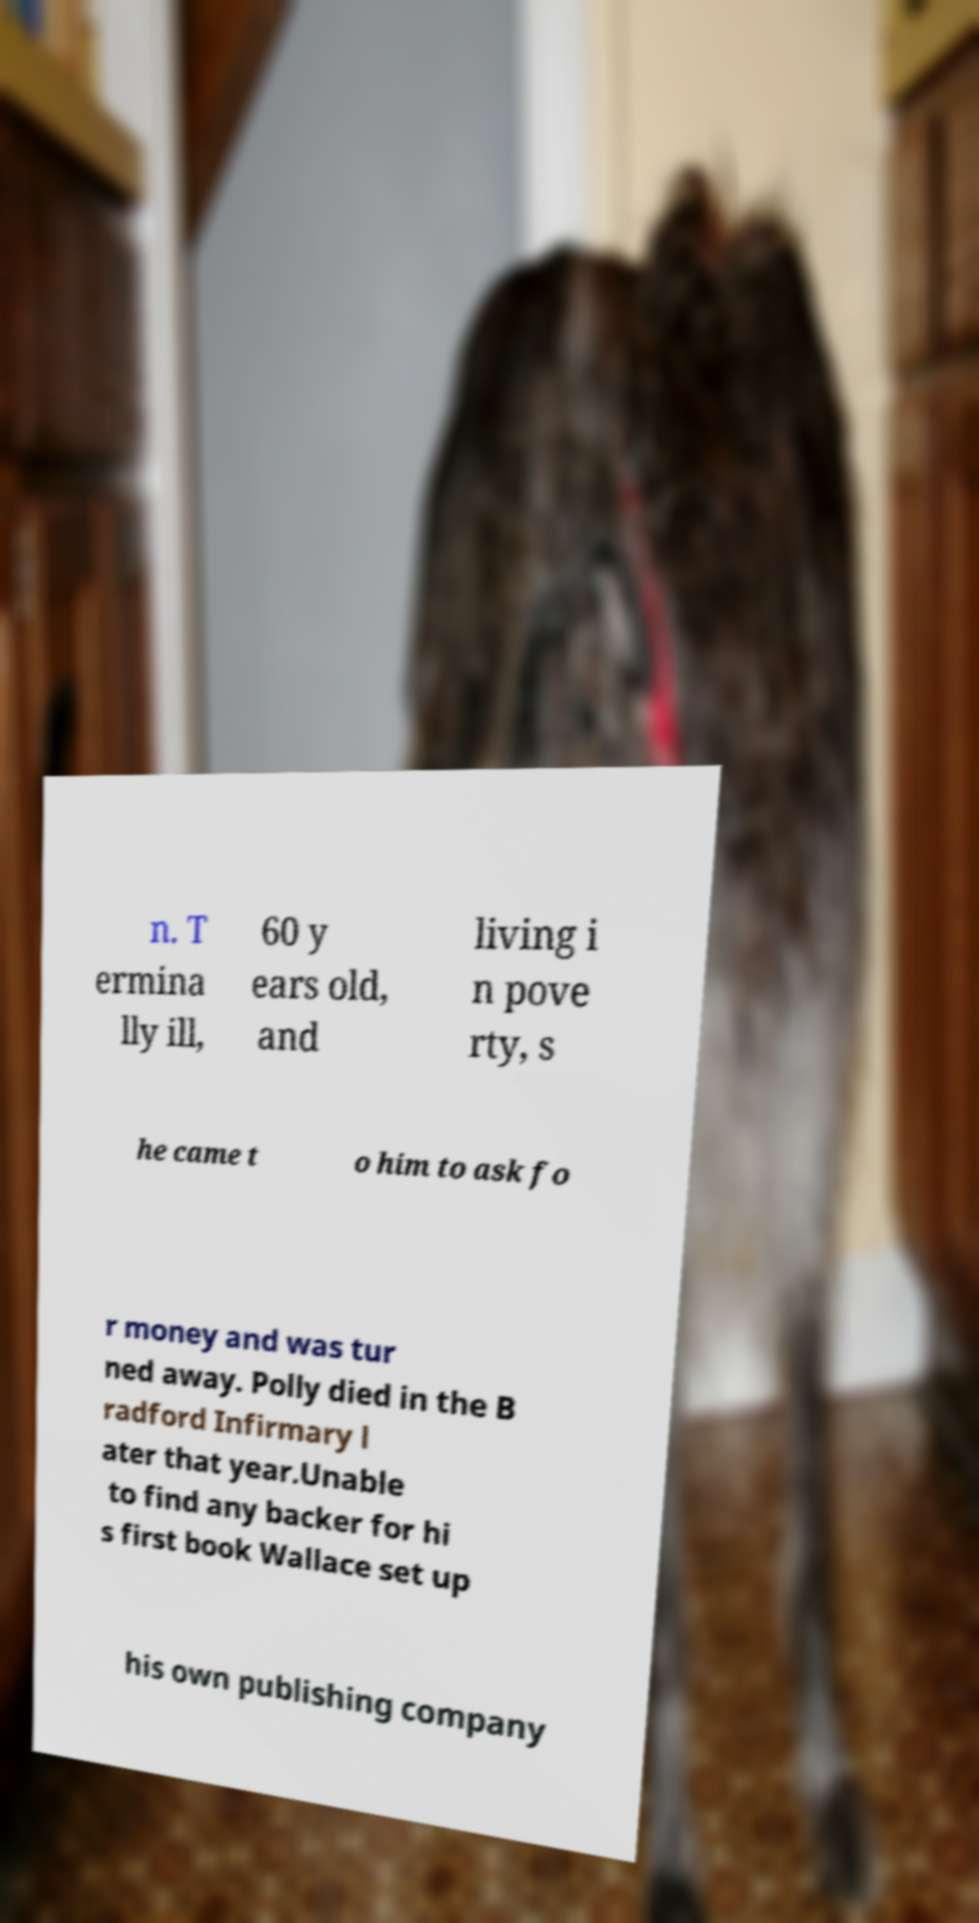Can you accurately transcribe the text from the provided image for me? n. T ermina lly ill, 60 y ears old, and living i n pove rty, s he came t o him to ask fo r money and was tur ned away. Polly died in the B radford Infirmary l ater that year.Unable to find any backer for hi s first book Wallace set up his own publishing company 